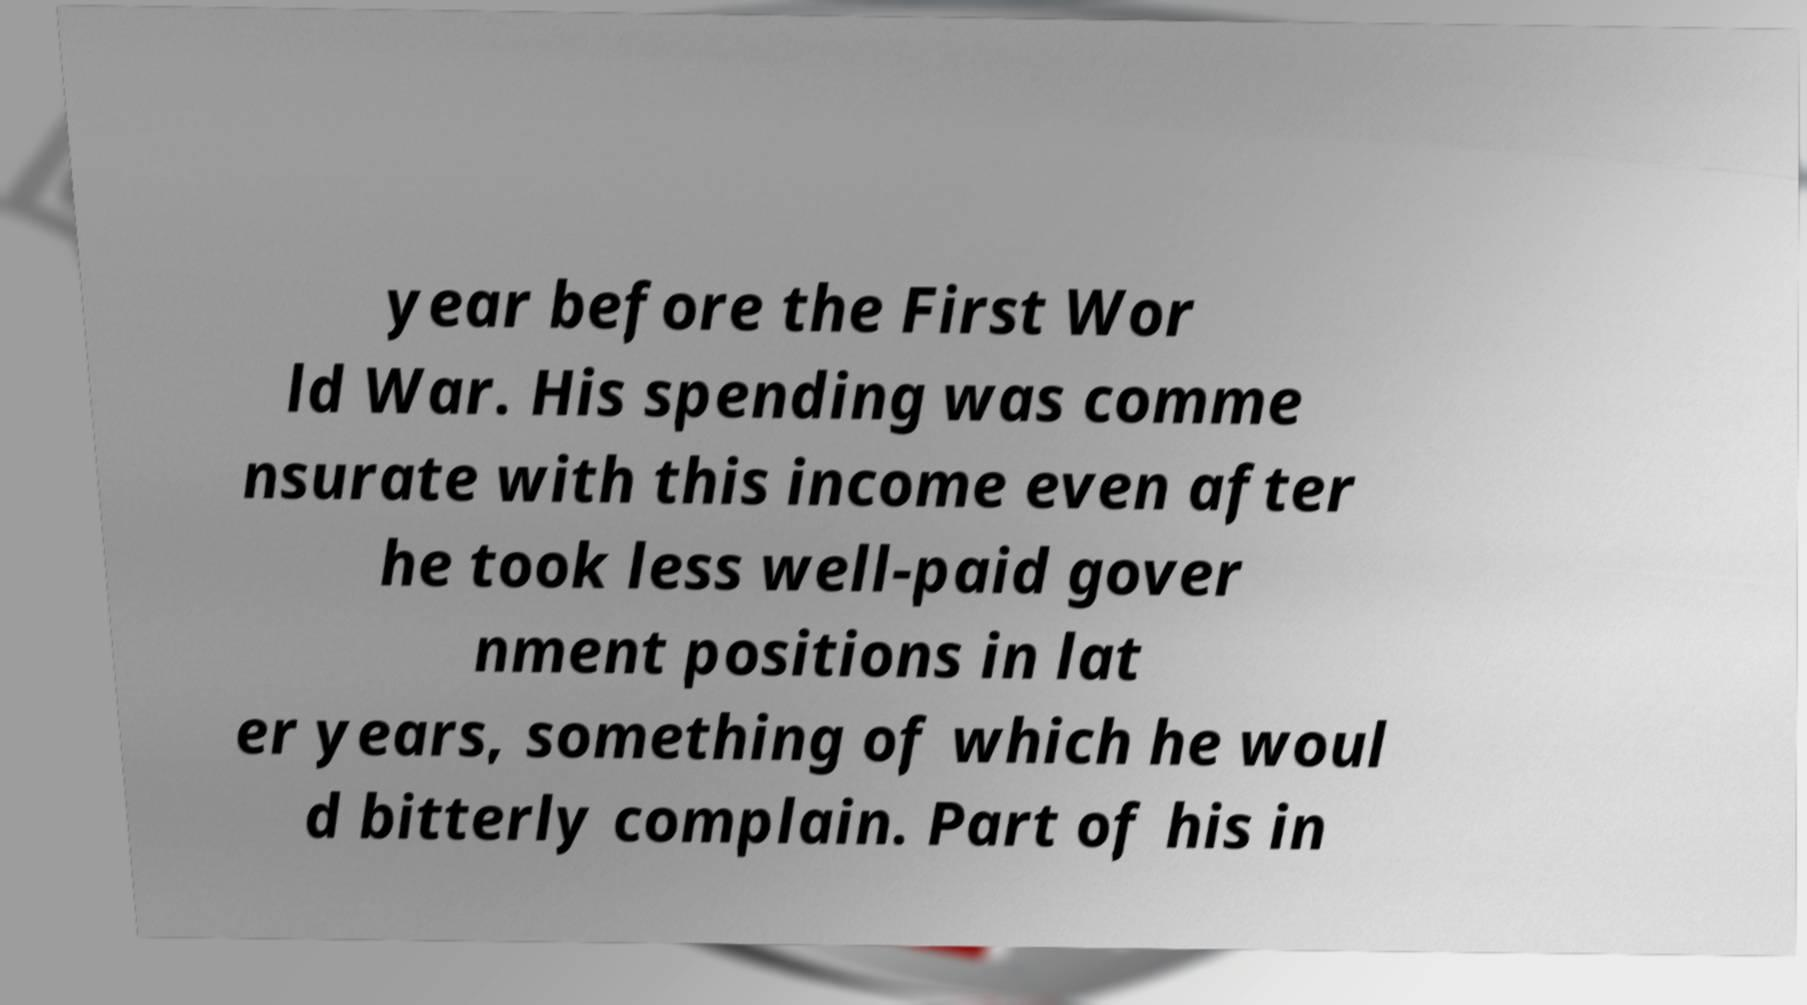Could you extract and type out the text from this image? year before the First Wor ld War. His spending was comme nsurate with this income even after he took less well-paid gover nment positions in lat er years, something of which he woul d bitterly complain. Part of his in 